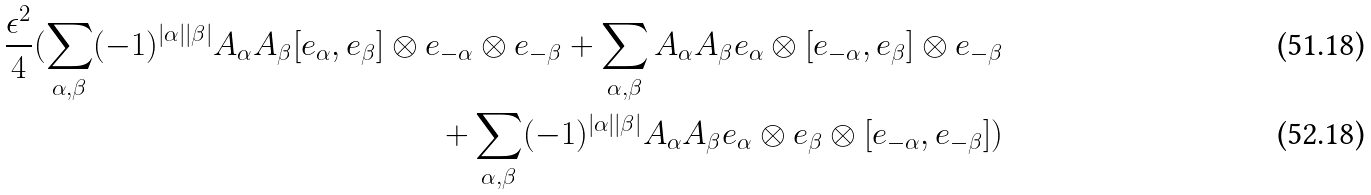<formula> <loc_0><loc_0><loc_500><loc_500>\frac { \epsilon ^ { 2 } } { 4 } ( \sum _ { \alpha , \beta } ( - 1 ) ^ { | \alpha | | \beta | } A _ { \alpha } A _ { \beta } [ e _ { \alpha } , e _ { \beta } ] \otimes e _ { - \alpha } \otimes e _ { - \beta } + \sum _ { \alpha , \beta } A _ { \alpha } A _ { \beta } e _ { \alpha } \otimes [ e _ { - \alpha } , e _ { \beta } ] \otimes e _ { - \beta } \\ + \sum _ { \alpha , \beta } ( - 1 ) ^ { | \alpha | | \beta | } A _ { \alpha } A _ { \beta } e _ { \alpha } \otimes e _ { \beta } \otimes [ e _ { - \alpha } , e _ { - \beta } ] )</formula> 